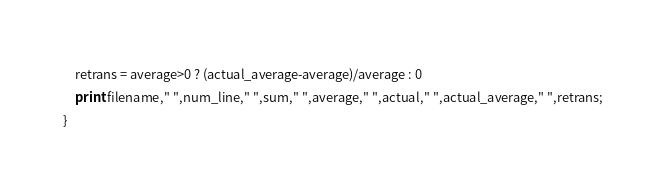<code> <loc_0><loc_0><loc_500><loc_500><_Awk_>    retrans = average>0 ? (actual_average-average)/average : 0
    print filename," ",num_line," ",sum," ",average," ",actual," ",actual_average," ",retrans;
}
</code> 